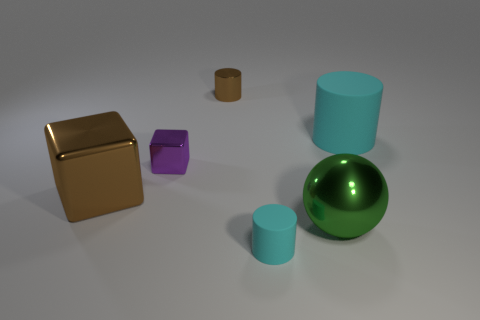Are there any other things that are the same size as the purple cube?
Provide a short and direct response. Yes. Are there any other things that have the same shape as the green thing?
Make the answer very short. No. The big thing that is to the left of the small cyan thing has what shape?
Your answer should be compact. Cube. Do the big green metal object and the large brown metallic thing have the same shape?
Provide a succinct answer. No. Is the number of large rubber things in front of the tiny purple metal cube the same as the number of big gray spheres?
Offer a very short reply. Yes. The small cyan rubber thing is what shape?
Offer a terse response. Cylinder. Is there anything else that is the same color as the big metal sphere?
Provide a short and direct response. No. There is a rubber thing on the right side of the large green metallic thing; is it the same size as the brown metallic thing that is in front of the purple shiny object?
Make the answer very short. Yes. There is a large shiny object on the left side of the small thing that is right of the tiny brown metal cylinder; what shape is it?
Provide a succinct answer. Cube. There is a purple block; does it have the same size as the brown shiny object in front of the purple cube?
Provide a succinct answer. No. 